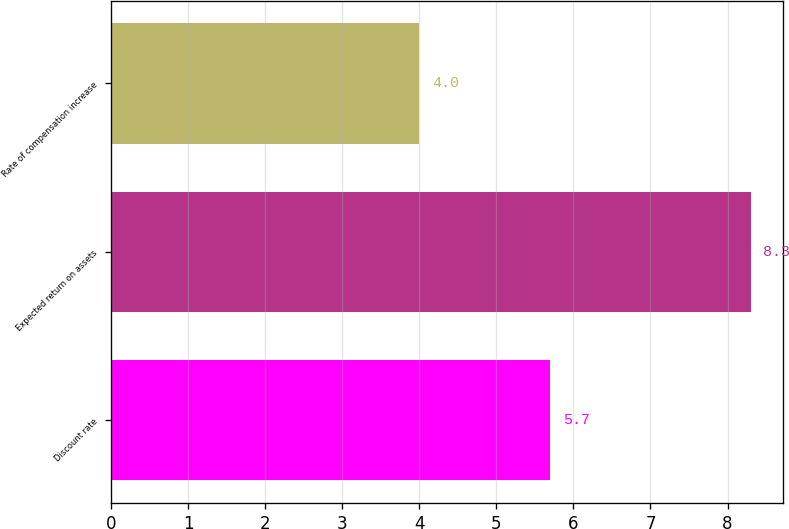Convert chart to OTSL. <chart><loc_0><loc_0><loc_500><loc_500><bar_chart><fcel>Discount rate<fcel>Expected return on assets<fcel>Rate of compensation increase<nl><fcel>5.7<fcel>8.3<fcel>4<nl></chart> 